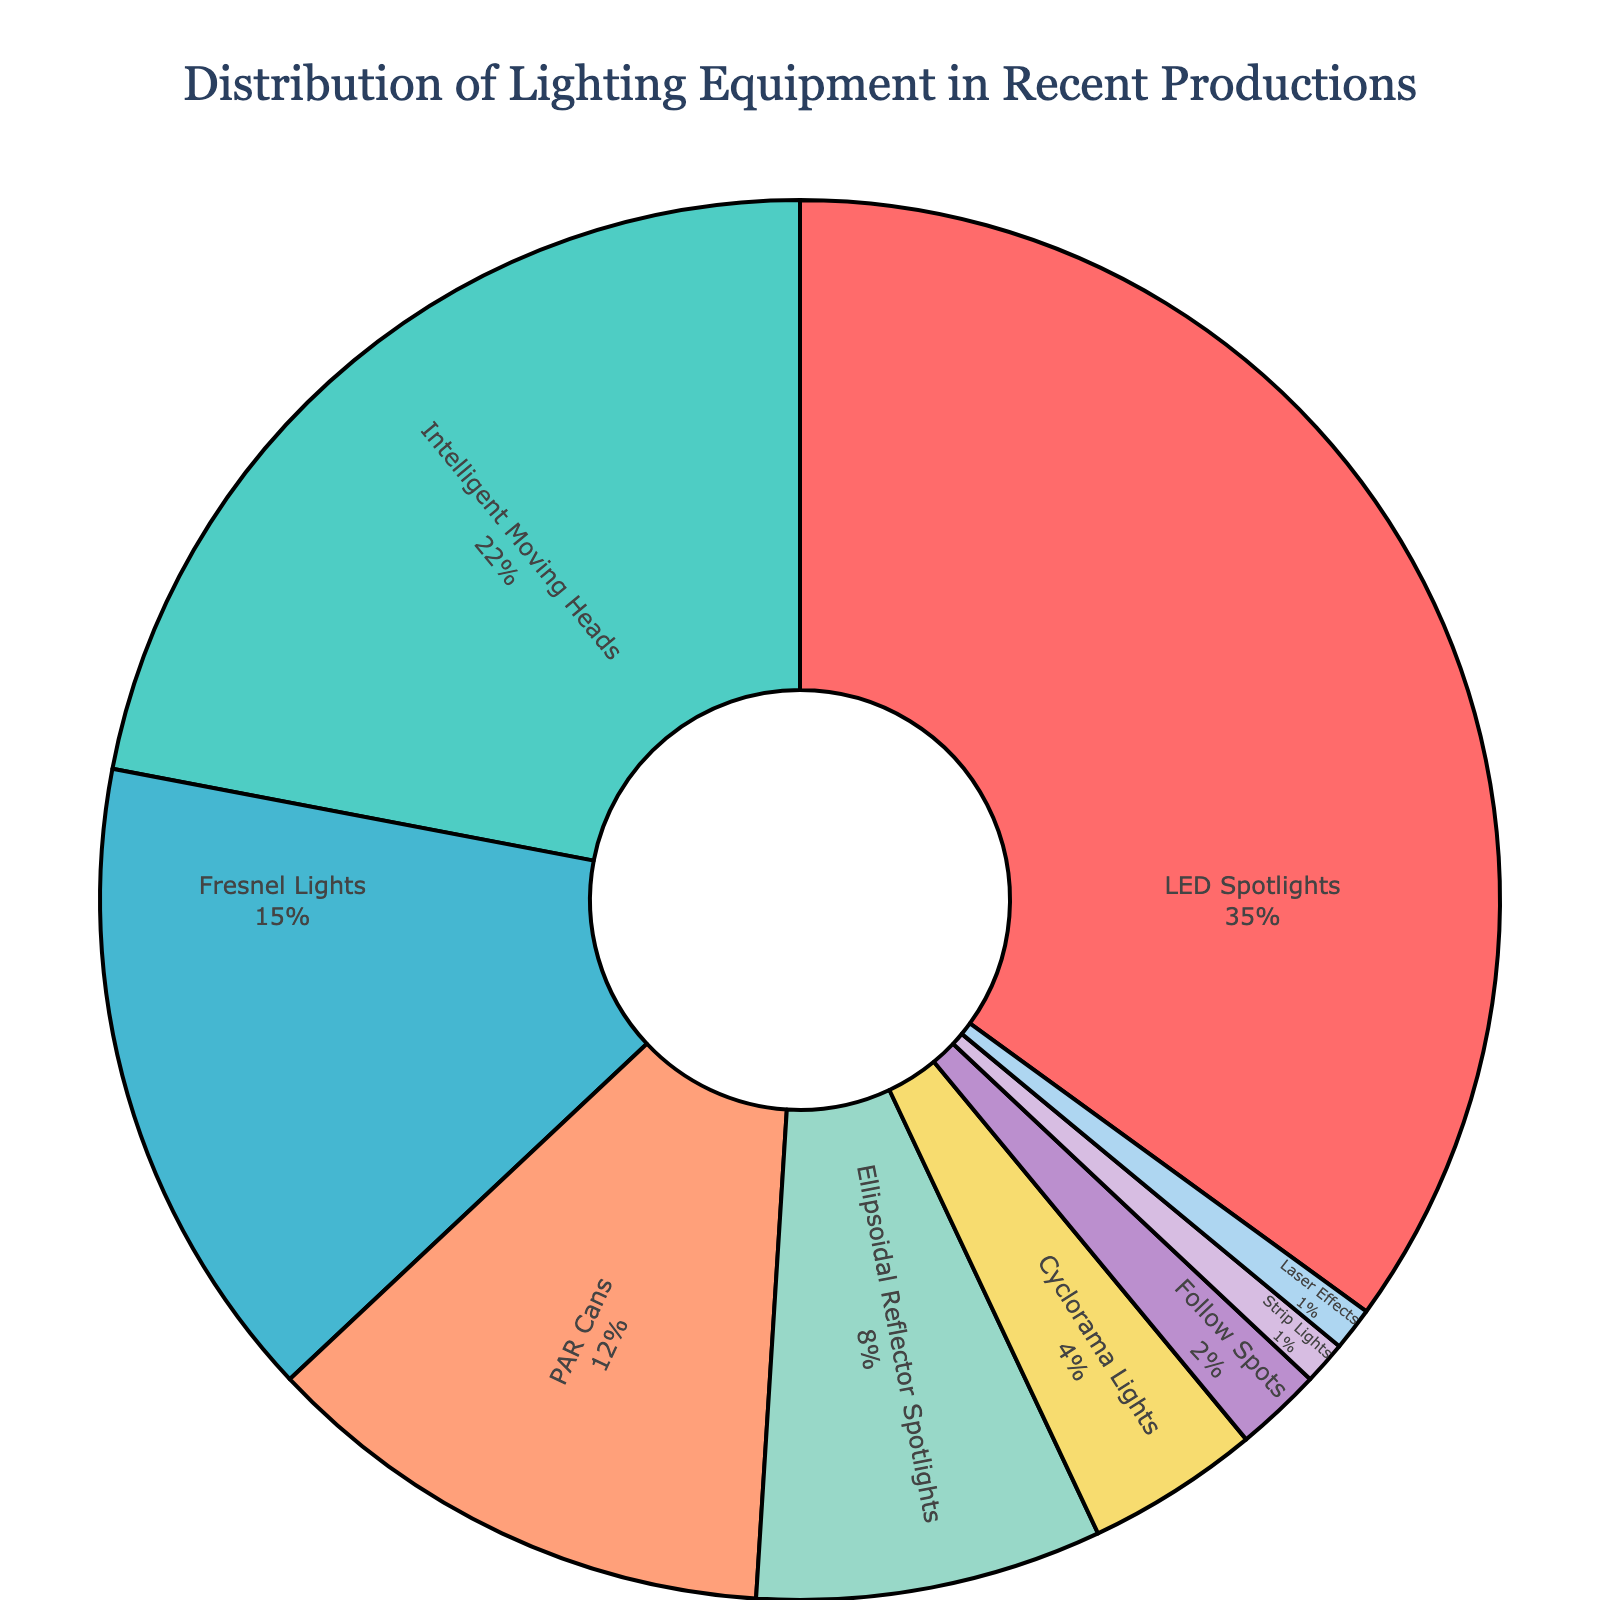Which equipment type has the highest percentage in the distribution? The figure shows that LED Spotlights have the largest section in the pie chart with a percentage value indicated as 35%.
Answer: LED Spotlights What is the combined percentage of Fresnel Lights and PAR Cans? To find the combined percentage, add the percentages of Fresnel Lights and PAR Cans: 15% + 12% = 27%.
Answer: 27% Which two equipment types have the smallest percentages and what is their combined total? The two smallest sections in the pie chart are Strip Lights and Laser Effects, both with 1%. Their combined percentage is 1% + 1% = 2%.
Answer: Strip Lights, Laser Effects, 2% What percentage of the equipment is comprised of intelligent lighting (LED Spotlights and Intelligent Moving Heads)? Adding the percentages of LED Spotlights and Intelligent Moving Heads: 35% + 22% = 57%.
Answer: 57% Which equipment type has twice the percentage of Follow Spots? Follow Spots have a percentage of 2%. PAR Cans have 12%, which is six times the percentage of Follow Spots. However, Fresnel Lights with 15% is closest to double, being 7.5 times. But none are exactly twice.
Answer: None Which color represents Intelligent Moving Heads? In the pie chart, Intelligent Moving Heads is represented by a green section.
Answer: Green What is the difference in percentage between the largest and smallest equipment types used? The largest percentage is LED Spotlights at 35%, and the smallest are Strip Lights and Laser Effects at 1%. The difference is 35% - 1% = 34%.
Answer: 34% How many equipment types have a percentage higher than 10%? The equipment types with percentages higher than 10% are LED Spotlights (35%), Intelligent Moving Heads (22%), Fresnel Lights (15%), and PAR Cans (12%). This gives a total of 4 equipment types.
Answer: 4 Which equipment type has a percentage closest to the average percentage of all the equipment types? The average percentage is obtained by summing all percentages and dividing by the number of types (100%/9 ≈ 11.1%). Closest to this is Ellipsoidal Reflector Spotlights at 8%.
Answer: Ellipsoidal Reflector Spotlights 